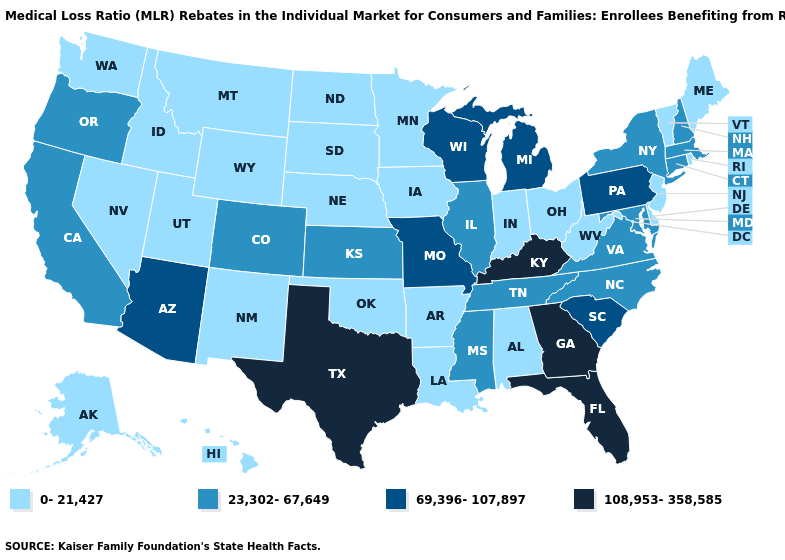What is the value of Kentucky?
Answer briefly. 108,953-358,585. Does the map have missing data?
Write a very short answer. No. What is the value of Vermont?
Write a very short answer. 0-21,427. Among the states that border Indiana , which have the highest value?
Be succinct. Kentucky. What is the highest value in the MidWest ?
Keep it brief. 69,396-107,897. Does New York have a lower value than Wisconsin?
Write a very short answer. Yes. Among the states that border Iowa , does Minnesota have the lowest value?
Answer briefly. Yes. Which states have the lowest value in the USA?
Write a very short answer. Alabama, Alaska, Arkansas, Delaware, Hawaii, Idaho, Indiana, Iowa, Louisiana, Maine, Minnesota, Montana, Nebraska, Nevada, New Jersey, New Mexico, North Dakota, Ohio, Oklahoma, Rhode Island, South Dakota, Utah, Vermont, Washington, West Virginia, Wyoming. Name the states that have a value in the range 0-21,427?
Concise answer only. Alabama, Alaska, Arkansas, Delaware, Hawaii, Idaho, Indiana, Iowa, Louisiana, Maine, Minnesota, Montana, Nebraska, Nevada, New Jersey, New Mexico, North Dakota, Ohio, Oklahoma, Rhode Island, South Dakota, Utah, Vermont, Washington, West Virginia, Wyoming. Name the states that have a value in the range 69,396-107,897?
Short answer required. Arizona, Michigan, Missouri, Pennsylvania, South Carolina, Wisconsin. What is the value of North Carolina?
Short answer required. 23,302-67,649. Which states hav the highest value in the MidWest?
Write a very short answer. Michigan, Missouri, Wisconsin. What is the highest value in the South ?
Quick response, please. 108,953-358,585. Name the states that have a value in the range 23,302-67,649?
Answer briefly. California, Colorado, Connecticut, Illinois, Kansas, Maryland, Massachusetts, Mississippi, New Hampshire, New York, North Carolina, Oregon, Tennessee, Virginia. 